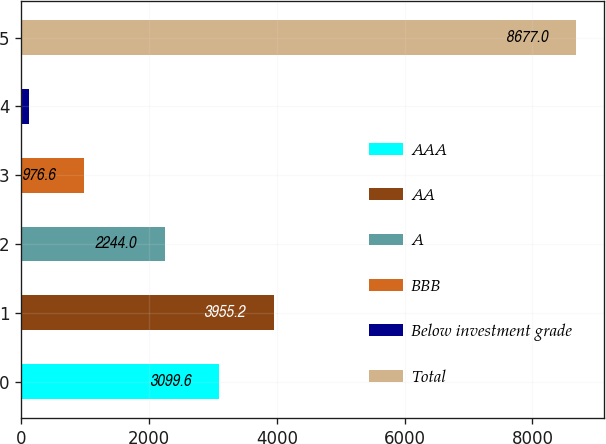<chart> <loc_0><loc_0><loc_500><loc_500><bar_chart><fcel>AAA<fcel>AA<fcel>A<fcel>BBB<fcel>Below investment grade<fcel>Total<nl><fcel>3099.6<fcel>3955.2<fcel>2244<fcel>976.6<fcel>121<fcel>8677<nl></chart> 